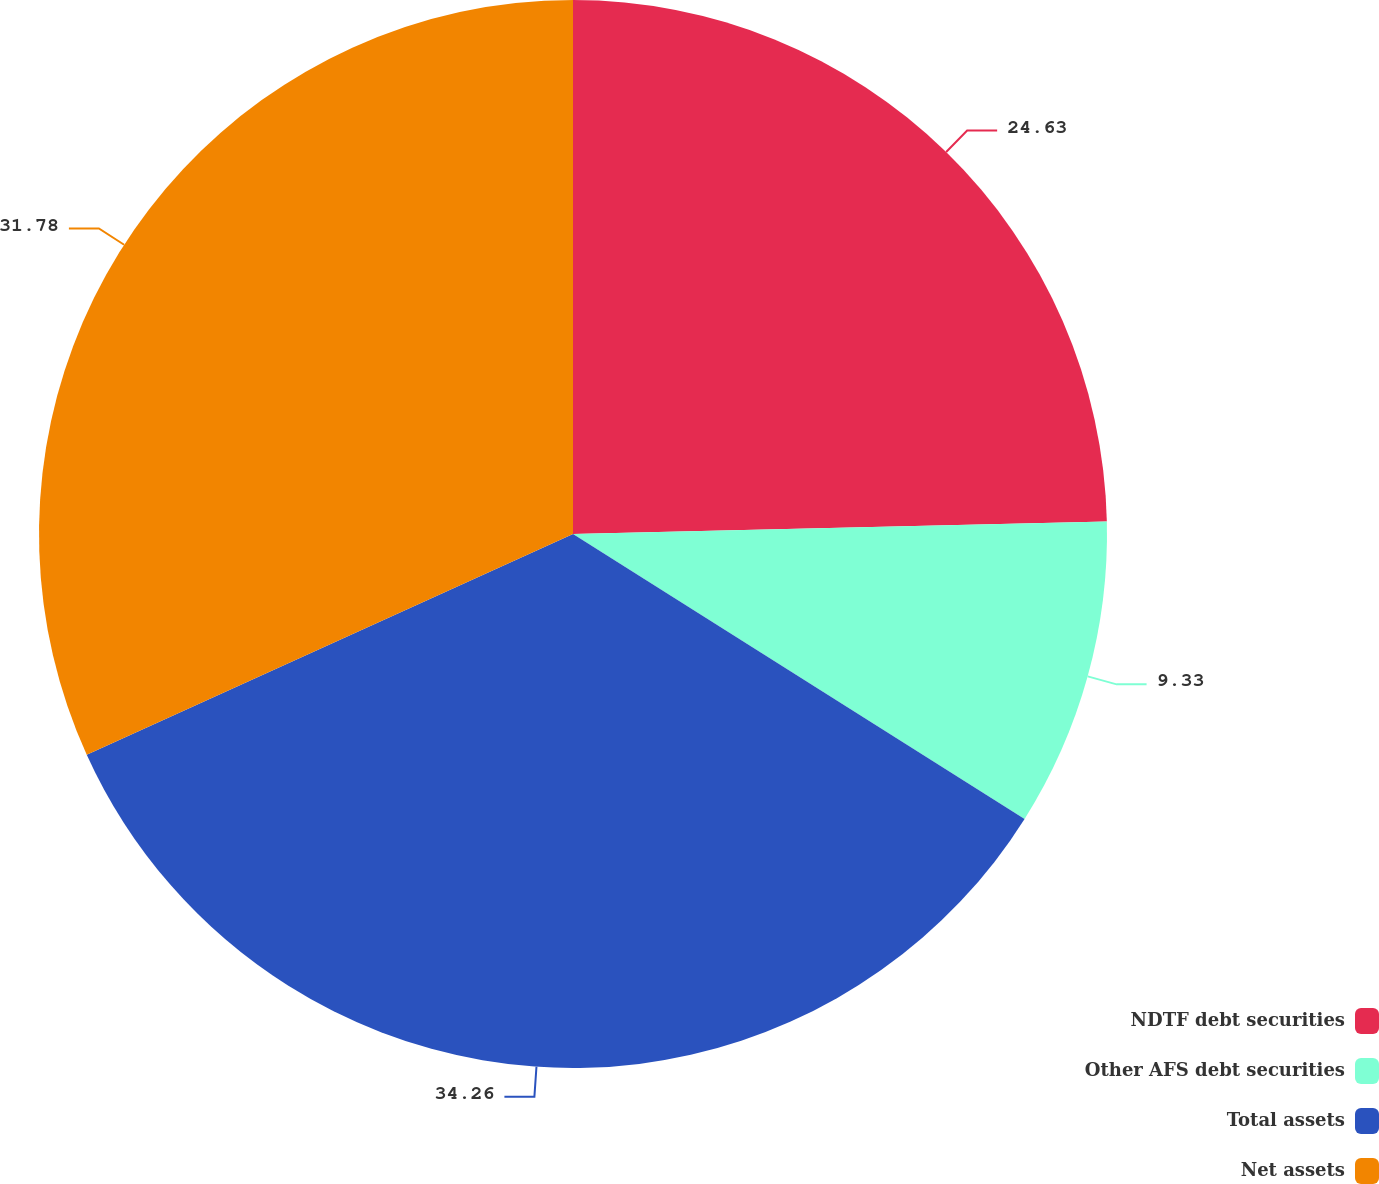<chart> <loc_0><loc_0><loc_500><loc_500><pie_chart><fcel>NDTF debt securities<fcel>Other AFS debt securities<fcel>Total assets<fcel>Net assets<nl><fcel>24.63%<fcel>9.33%<fcel>34.26%<fcel>31.78%<nl></chart> 